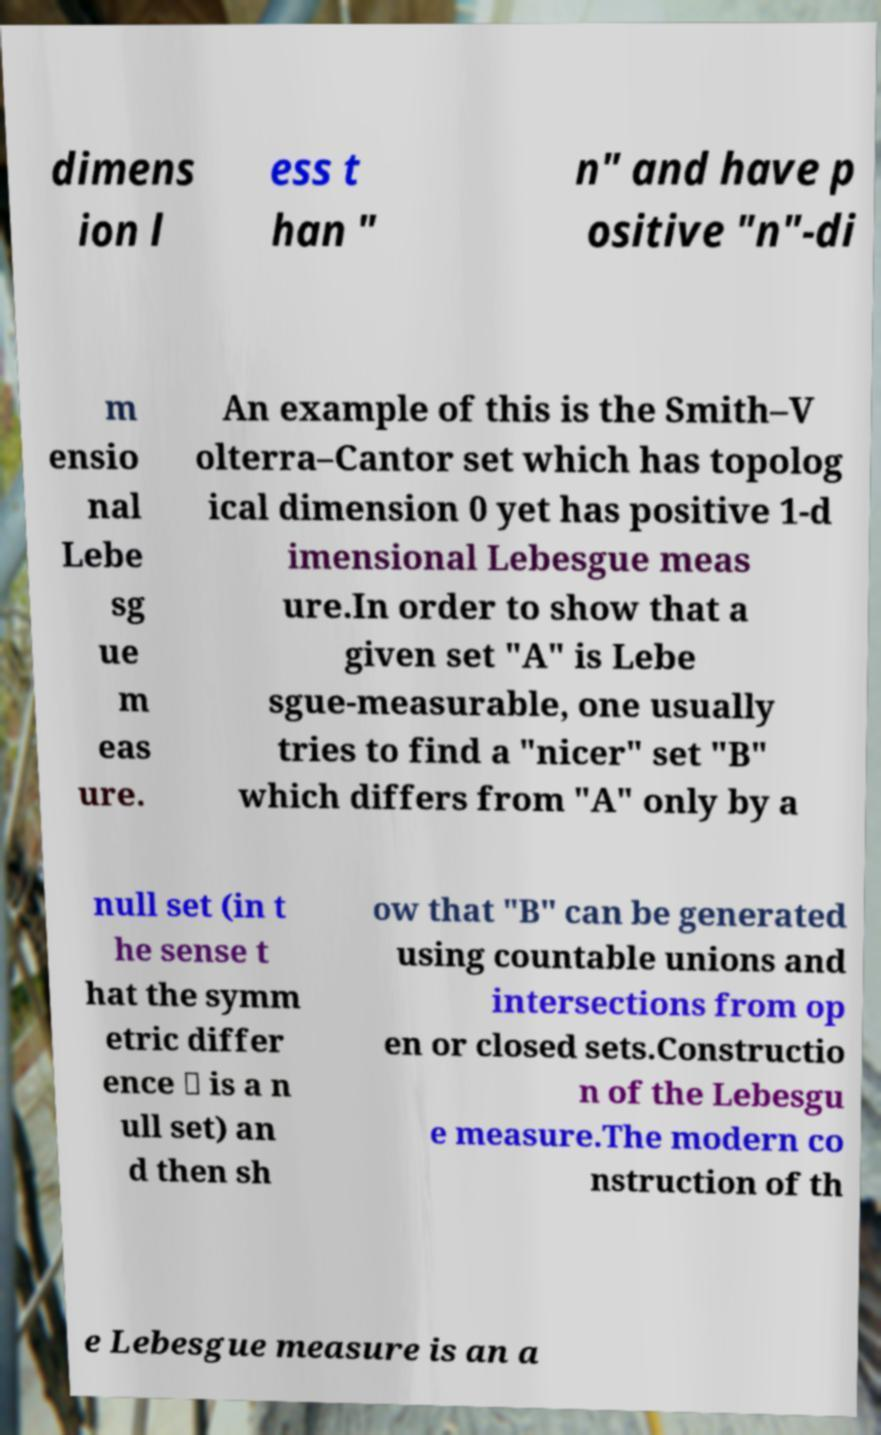Please read and relay the text visible in this image. What does it say? dimens ion l ess t han " n" and have p ositive "n"-di m ensio nal Lebe sg ue m eas ure. An example of this is the Smith–V olterra–Cantor set which has topolog ical dimension 0 yet has positive 1-d imensional Lebesgue meas ure.In order to show that a given set "A" is Lebe sgue-measurable, one usually tries to find a "nicer" set "B" which differs from "A" only by a null set (in t he sense t hat the symm etric differ ence ∪ is a n ull set) an d then sh ow that "B" can be generated using countable unions and intersections from op en or closed sets.Constructio n of the Lebesgu e measure.The modern co nstruction of th e Lebesgue measure is an a 